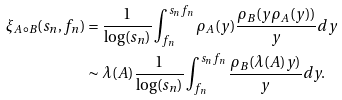<formula> <loc_0><loc_0><loc_500><loc_500>\xi _ { A \circ B } ( s _ { n } , f _ { n } ) & = \frac { 1 } { \log ( s _ { n } ) } \int _ { f _ { n } } ^ { s _ { n } f _ { n } } \rho _ { A } ( y ) \frac { \rho _ { B } ( y \rho _ { A } ( y ) ) } { y } d y \\ & \sim \lambda ( A ) \frac { 1 } { \log ( s _ { n } ) } \int _ { f _ { n } } ^ { s _ { n } f _ { n } } \frac { \rho _ { B } ( \lambda ( A ) y ) } { y } d y .</formula> 